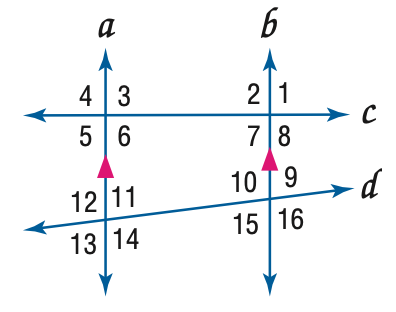Answer the mathemtical geometry problem and directly provide the correct option letter.
Question: In the figure, m \angle 4 = 104, m \angle 14 = 118. Find the measure of \angle 9.
Choices: A: 62 B: 76 C: 104 D: 118 A 